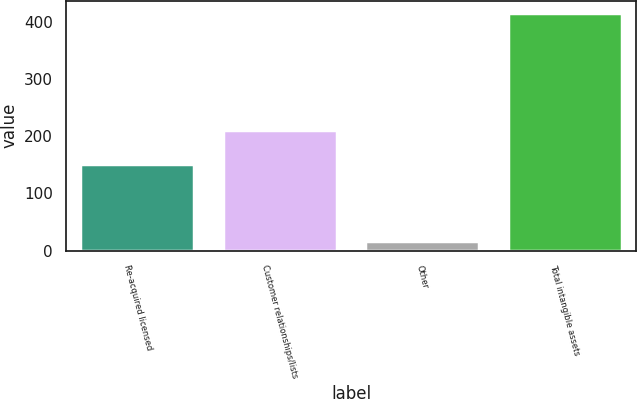<chart> <loc_0><loc_0><loc_500><loc_500><bar_chart><fcel>Re-acquired licensed<fcel>Customer relationships/lists<fcel>Other<fcel>Total intangible assets<nl><fcel>150.7<fcel>211.5<fcel>16.7<fcel>416<nl></chart> 